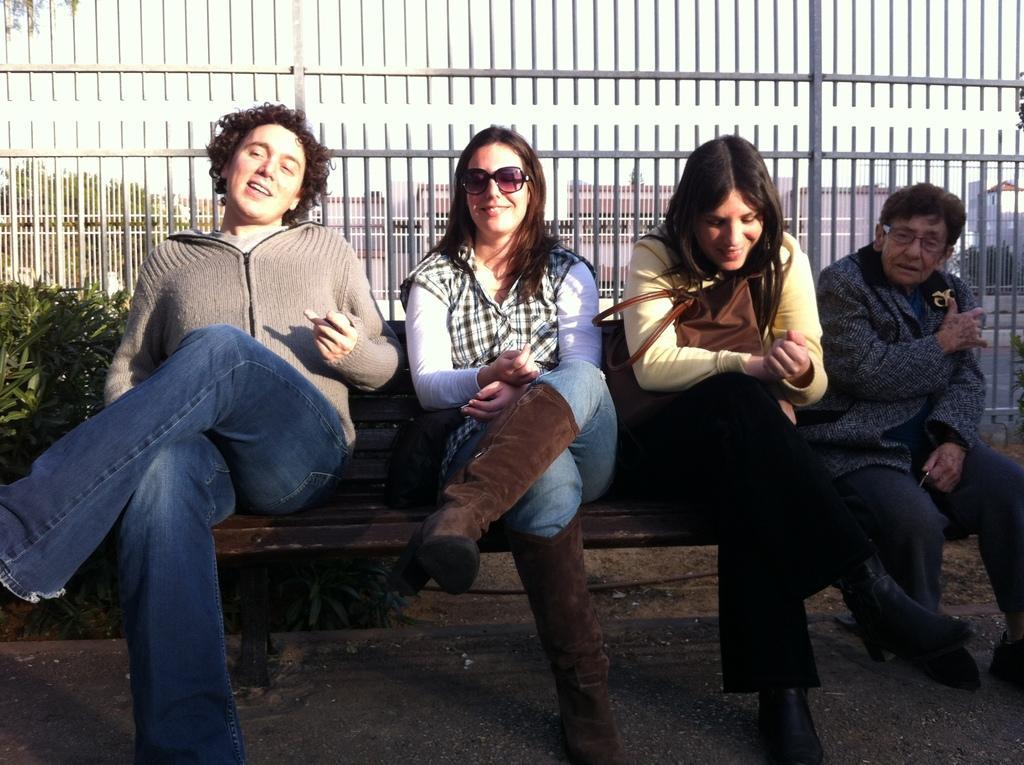Describe this image in one or two sentences. This picture describes about group of people, few people wore spectacles and they are all seated on the bench, behind them we can see plants, metal rods, trees and buildings. 